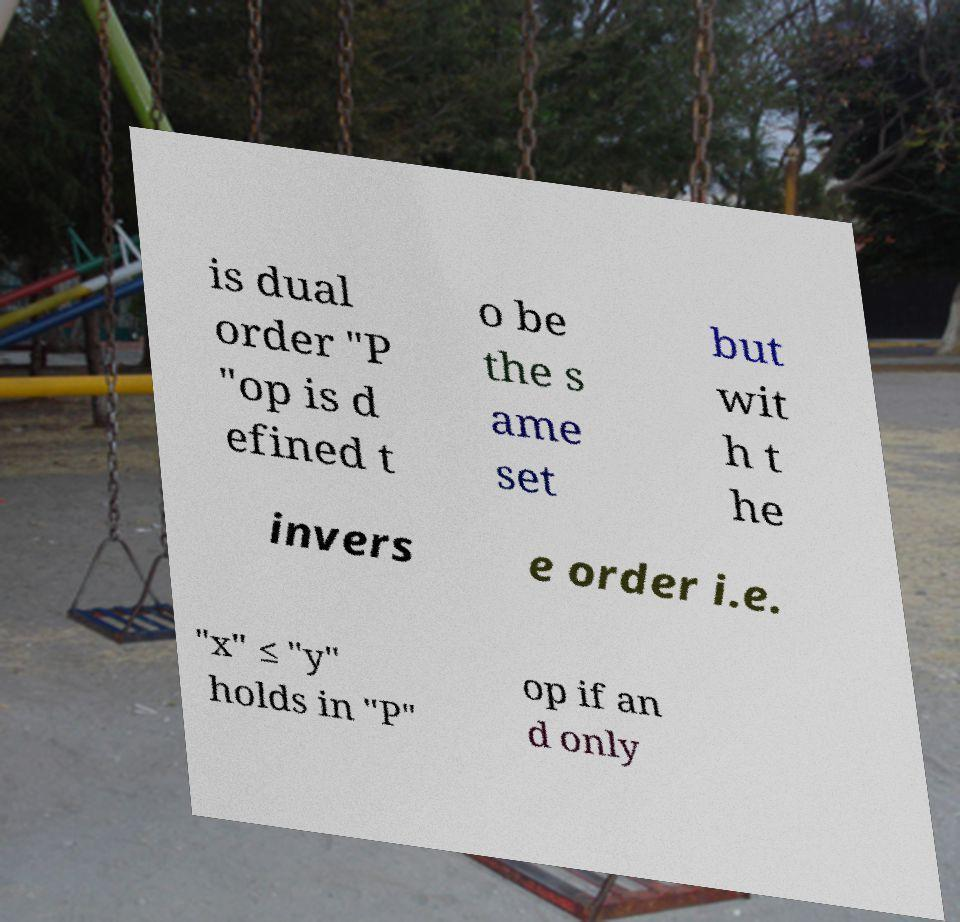There's text embedded in this image that I need extracted. Can you transcribe it verbatim? is dual order "P "op is d efined t o be the s ame set but wit h t he invers e order i.e. "x" ≤ "y" holds in "P" op if an d only 